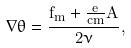Convert formula to latex. <formula><loc_0><loc_0><loc_500><loc_500>\nabla \theta = \frac { f _ { m } + \frac { e } { c m } A } { 2 \nu } ,</formula> 